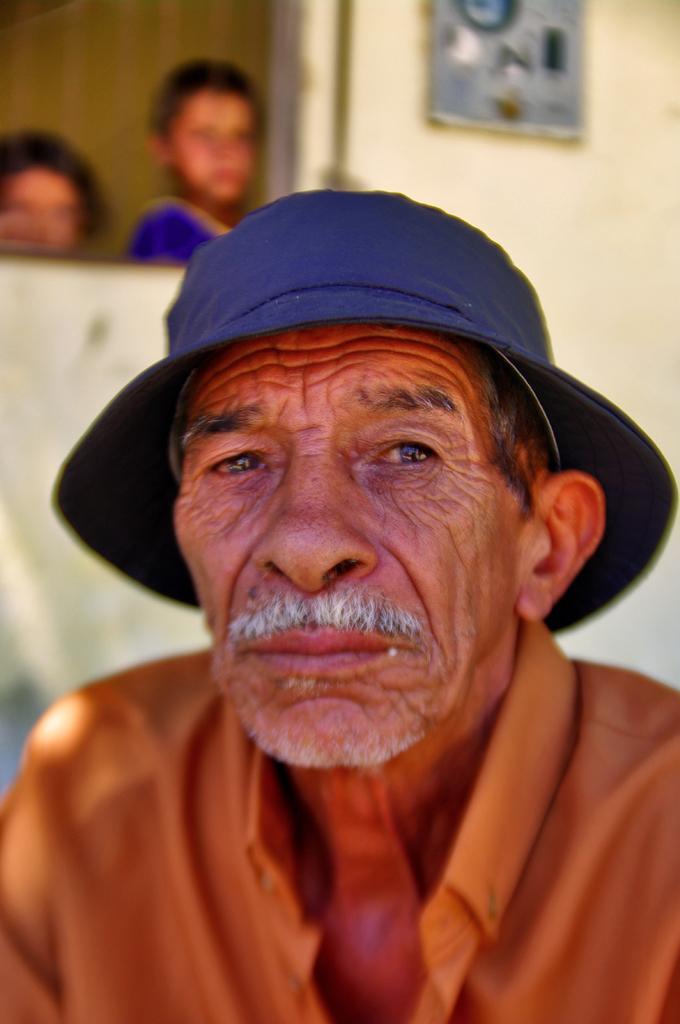Please provide a concise description of this image. In the center of the image, we can see a man wearing a hat and in the background, there are kids and we can an object on the wall. 